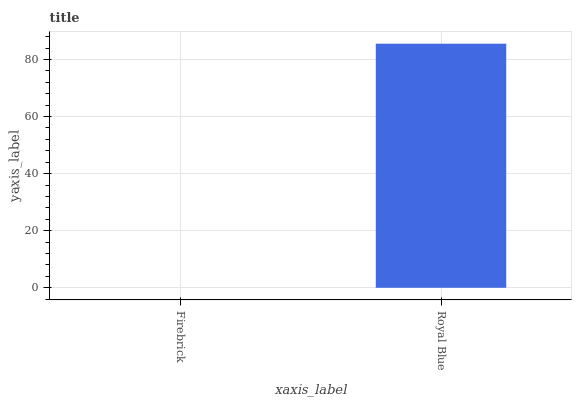Is Firebrick the minimum?
Answer yes or no. Yes. Is Royal Blue the maximum?
Answer yes or no. Yes. Is Royal Blue the minimum?
Answer yes or no. No. Is Royal Blue greater than Firebrick?
Answer yes or no. Yes. Is Firebrick less than Royal Blue?
Answer yes or no. Yes. Is Firebrick greater than Royal Blue?
Answer yes or no. No. Is Royal Blue less than Firebrick?
Answer yes or no. No. Is Royal Blue the high median?
Answer yes or no. Yes. Is Firebrick the low median?
Answer yes or no. Yes. Is Firebrick the high median?
Answer yes or no. No. Is Royal Blue the low median?
Answer yes or no. No. 